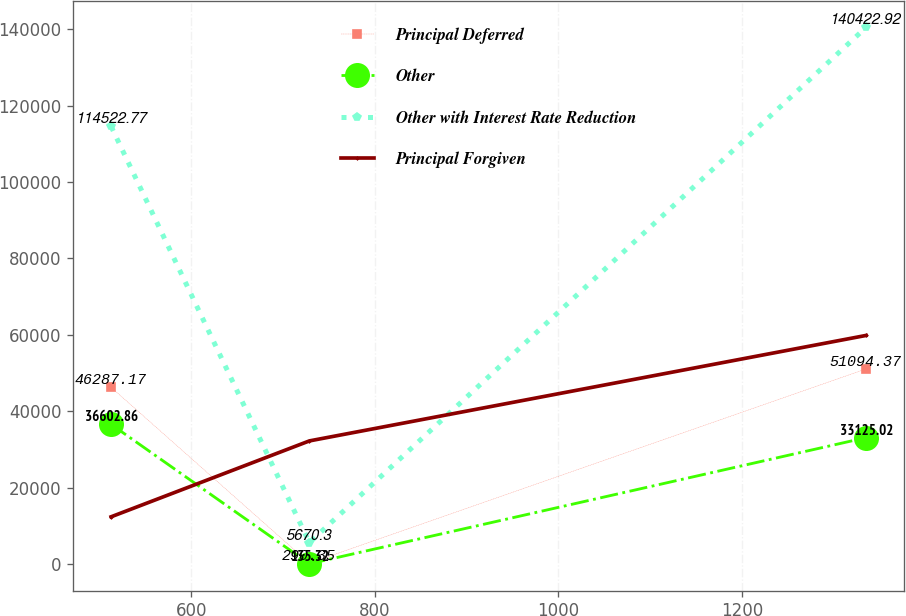<chart> <loc_0><loc_0><loc_500><loc_500><line_chart><ecel><fcel>Principal Deferred<fcel>Other<fcel>Other with Interest Rate Reduction<fcel>Principal Forgiven<nl><fcel>512.86<fcel>46287.2<fcel>36602.9<fcel>114523<fcel>12429.1<nl><fcel>728.84<fcel>290.35<fcel>135.32<fcel>5670.3<fcel>32277.5<nl><fcel>1335.07<fcel>51094.4<fcel>33125<fcel>140423<fcel>59857.7<nl></chart> 